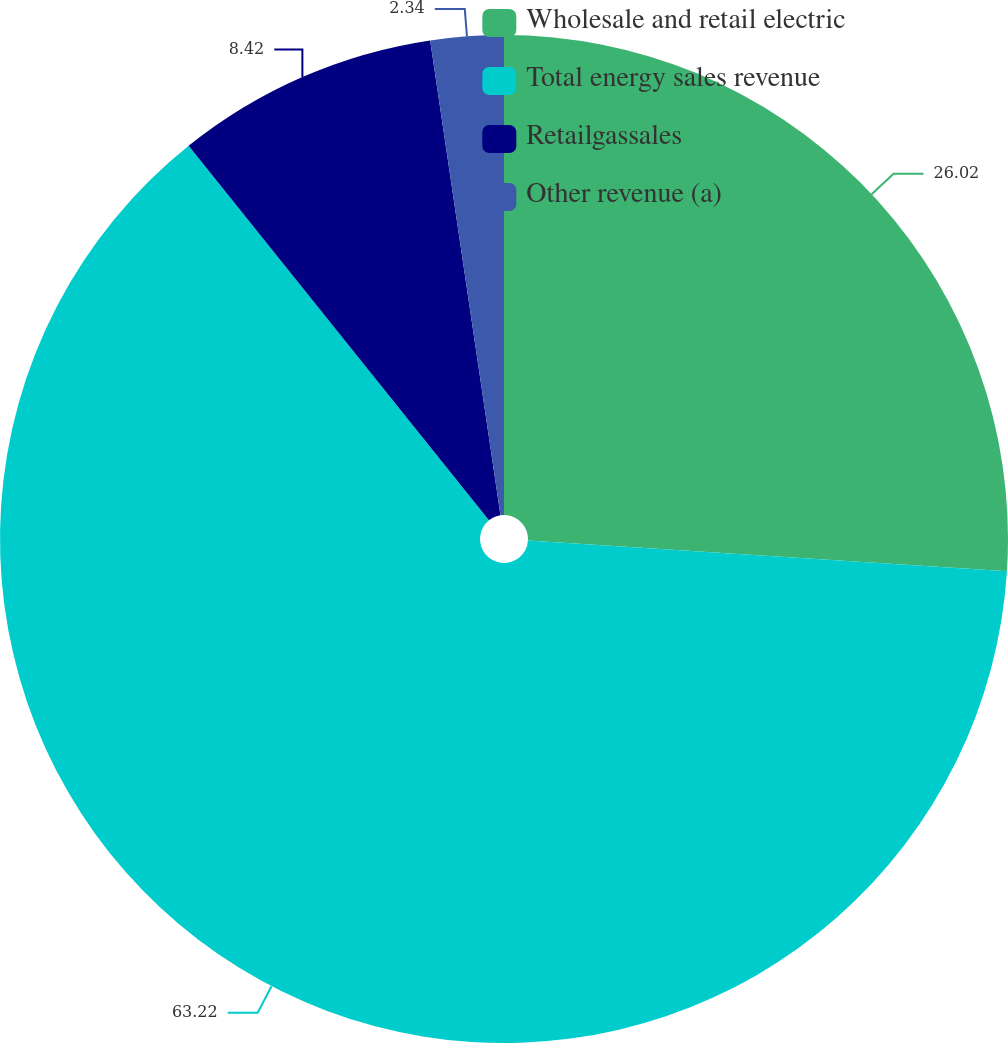Convert chart to OTSL. <chart><loc_0><loc_0><loc_500><loc_500><pie_chart><fcel>Wholesale and retail electric<fcel>Total energy sales revenue<fcel>Retailgassales<fcel>Other revenue (a)<nl><fcel>26.02%<fcel>63.22%<fcel>8.42%<fcel>2.34%<nl></chart> 